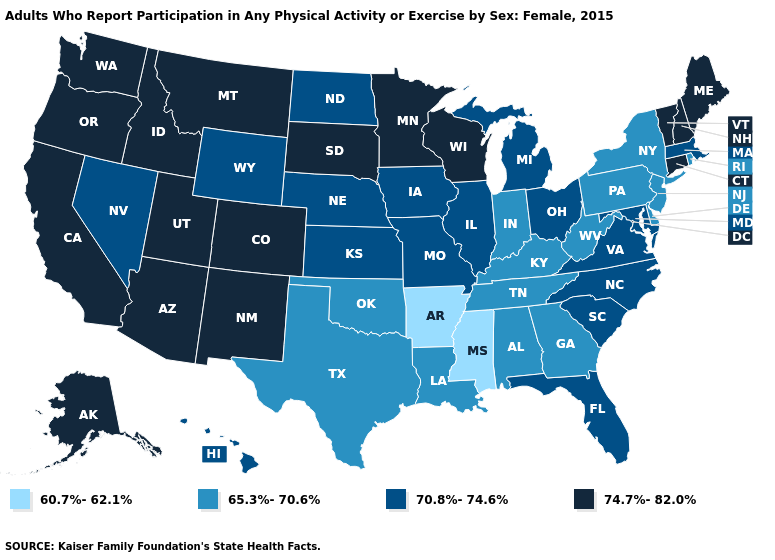What is the lowest value in states that border Vermont?
Short answer required. 65.3%-70.6%. Does Connecticut have a lower value than South Dakota?
Be succinct. No. What is the highest value in the USA?
Give a very brief answer. 74.7%-82.0%. Name the states that have a value in the range 60.7%-62.1%?
Give a very brief answer. Arkansas, Mississippi. What is the value of Louisiana?
Short answer required. 65.3%-70.6%. What is the value of Oklahoma?
Short answer required. 65.3%-70.6%. What is the value of California?
Write a very short answer. 74.7%-82.0%. Does the first symbol in the legend represent the smallest category?
Keep it brief. Yes. What is the highest value in states that border New York?
Give a very brief answer. 74.7%-82.0%. Which states have the highest value in the USA?
Short answer required. Alaska, Arizona, California, Colorado, Connecticut, Idaho, Maine, Minnesota, Montana, New Hampshire, New Mexico, Oregon, South Dakota, Utah, Vermont, Washington, Wisconsin. Name the states that have a value in the range 65.3%-70.6%?
Keep it brief. Alabama, Delaware, Georgia, Indiana, Kentucky, Louisiana, New Jersey, New York, Oklahoma, Pennsylvania, Rhode Island, Tennessee, Texas, West Virginia. What is the value of New York?
Short answer required. 65.3%-70.6%. What is the highest value in the USA?
Answer briefly. 74.7%-82.0%. Name the states that have a value in the range 70.8%-74.6%?
Give a very brief answer. Florida, Hawaii, Illinois, Iowa, Kansas, Maryland, Massachusetts, Michigan, Missouri, Nebraska, Nevada, North Carolina, North Dakota, Ohio, South Carolina, Virginia, Wyoming. What is the value of Maine?
Be succinct. 74.7%-82.0%. 